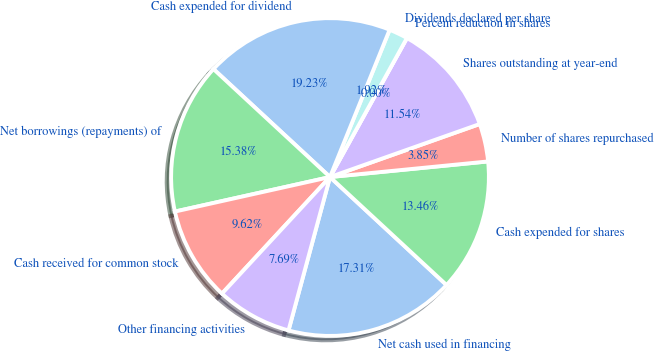<chart> <loc_0><loc_0><loc_500><loc_500><pie_chart><fcel>Net cash used in financing<fcel>Cash expended for shares<fcel>Number of shares repurchased<fcel>Shares outstanding at year-end<fcel>Percent reduction in shares<fcel>Dividends declared per share<fcel>Cash expended for dividend<fcel>Net borrowings (repayments) of<fcel>Cash received for common stock<fcel>Other financing activities<nl><fcel>17.31%<fcel>13.46%<fcel>3.85%<fcel>11.54%<fcel>0.0%<fcel>1.92%<fcel>19.23%<fcel>15.38%<fcel>9.62%<fcel>7.69%<nl></chart> 